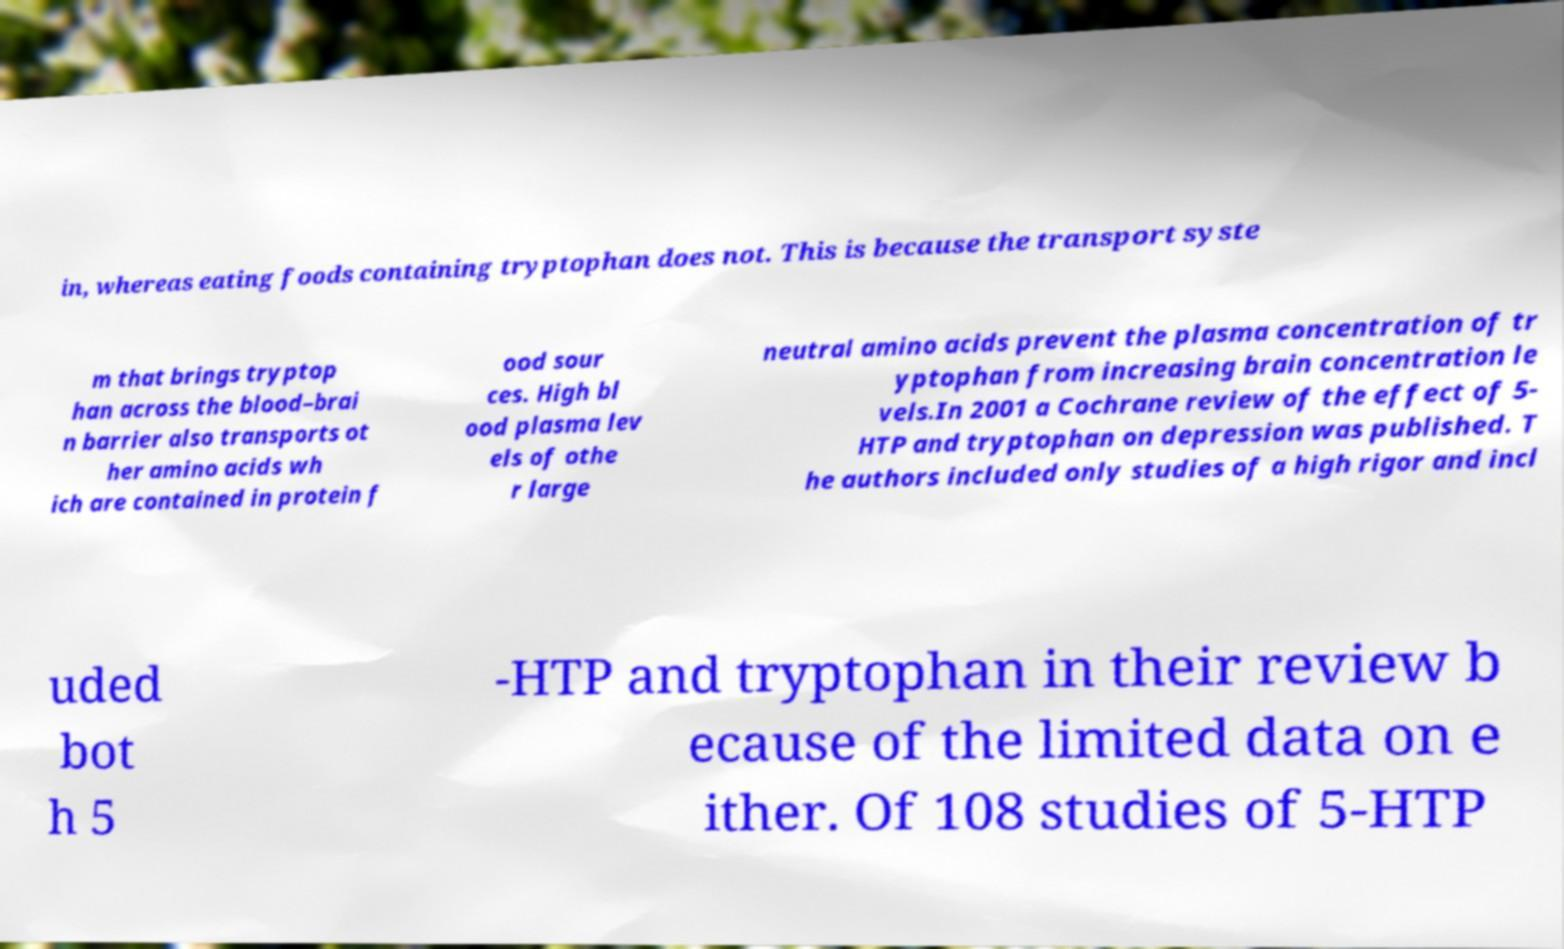Could you extract and type out the text from this image? in, whereas eating foods containing tryptophan does not. This is because the transport syste m that brings tryptop han across the blood–brai n barrier also transports ot her amino acids wh ich are contained in protein f ood sour ces. High bl ood plasma lev els of othe r large neutral amino acids prevent the plasma concentration of tr yptophan from increasing brain concentration le vels.In 2001 a Cochrane review of the effect of 5- HTP and tryptophan on depression was published. T he authors included only studies of a high rigor and incl uded bot h 5 -HTP and tryptophan in their review b ecause of the limited data on e ither. Of 108 studies of 5-HTP 